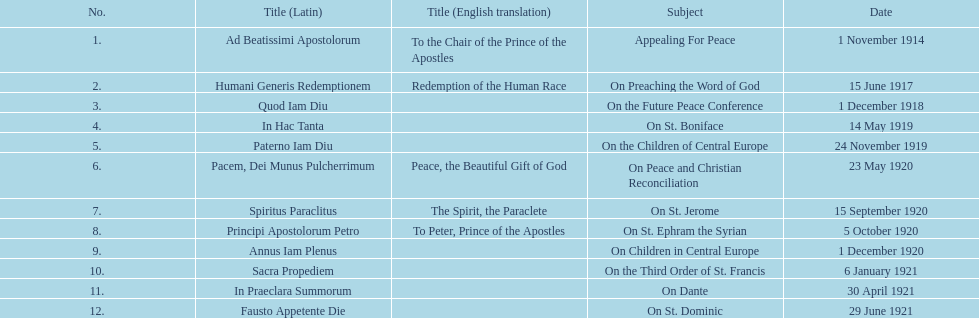What is the initial english translation mentioned in the chart? To the Chair of the Prince of the Apostles. 